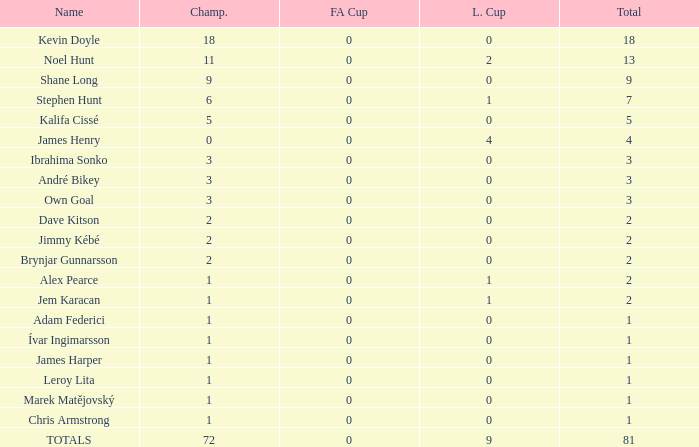What is the championship of Jem Karacan that has a total of 2 and a league cup more than 0? 1.0. 